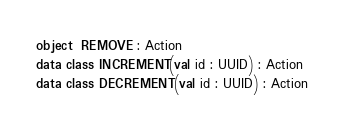Convert code to text. <code><loc_0><loc_0><loc_500><loc_500><_Kotlin_>object  REMOVE : Action
data class INCREMENT(val id : UUID) : Action
data class DECREMENT(val id : UUID) : Action
</code> 